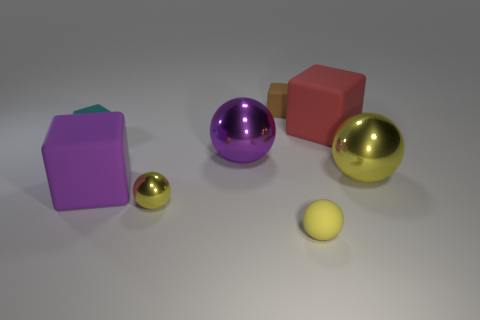Subtract all big purple metal spheres. How many spheres are left? 3 Subtract 2 blocks. How many blocks are left? 2 Subtract all brown cubes. How many yellow spheres are left? 3 Subtract all purple cubes. How many cubes are left? 3 Add 1 small green rubber balls. How many objects exist? 9 Subtract all blue cubes. Subtract all green balls. How many cubes are left? 4 Subtract 0 green cylinders. How many objects are left? 8 Subtract all red spheres. Subtract all tiny metallic spheres. How many objects are left? 7 Add 6 tiny cyan cubes. How many tiny cyan cubes are left? 7 Add 2 brown objects. How many brown objects exist? 3 